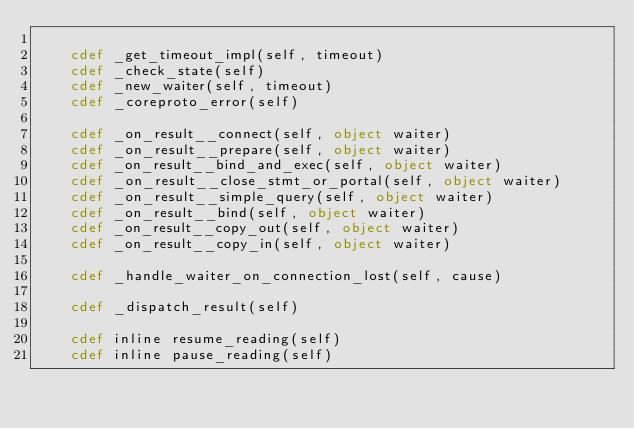Convert code to text. <code><loc_0><loc_0><loc_500><loc_500><_Cython_>
    cdef _get_timeout_impl(self, timeout)
    cdef _check_state(self)
    cdef _new_waiter(self, timeout)
    cdef _coreproto_error(self)

    cdef _on_result__connect(self, object waiter)
    cdef _on_result__prepare(self, object waiter)
    cdef _on_result__bind_and_exec(self, object waiter)
    cdef _on_result__close_stmt_or_portal(self, object waiter)
    cdef _on_result__simple_query(self, object waiter)
    cdef _on_result__bind(self, object waiter)
    cdef _on_result__copy_out(self, object waiter)
    cdef _on_result__copy_in(self, object waiter)

    cdef _handle_waiter_on_connection_lost(self, cause)

    cdef _dispatch_result(self)

    cdef inline resume_reading(self)
    cdef inline pause_reading(self)
</code> 